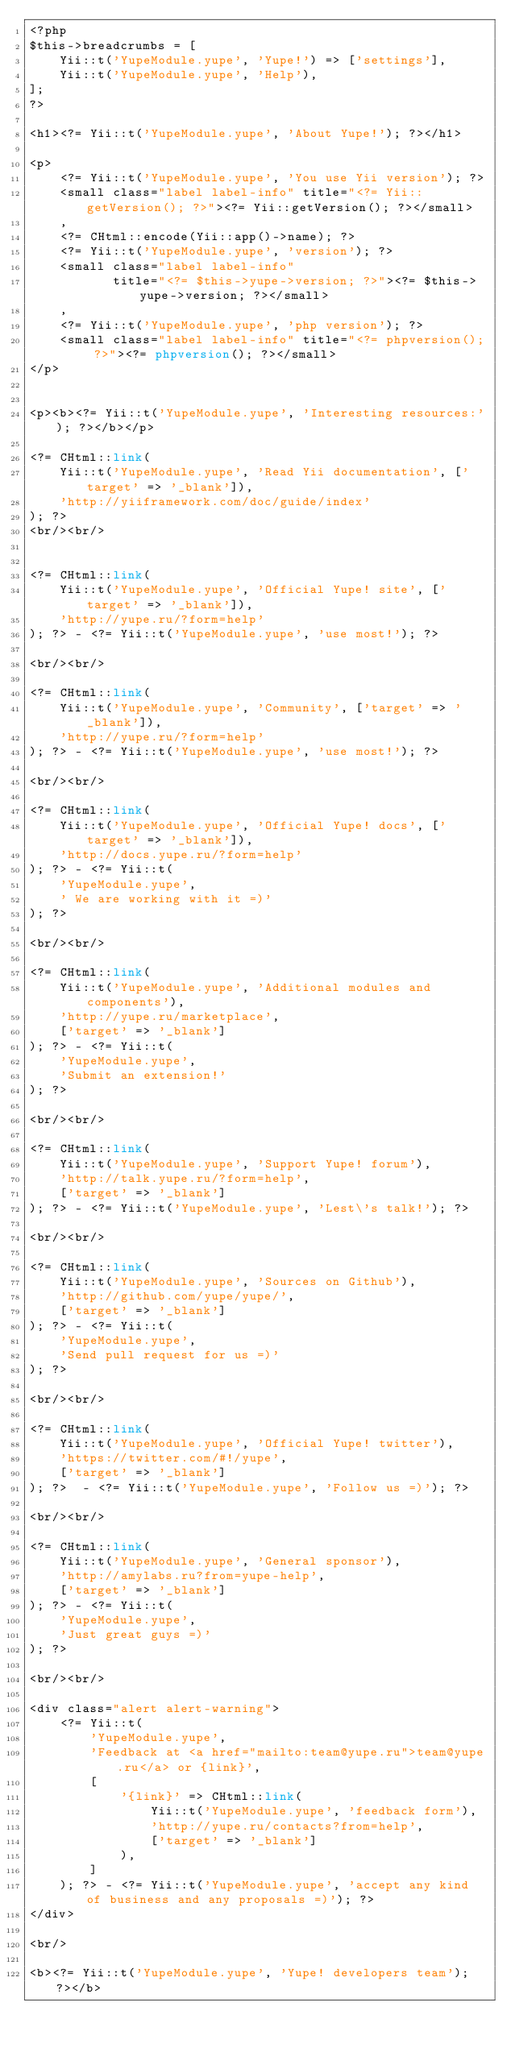<code> <loc_0><loc_0><loc_500><loc_500><_PHP_><?php
$this->breadcrumbs = [
    Yii::t('YupeModule.yupe', 'Yupe!') => ['settings'],
    Yii::t('YupeModule.yupe', 'Help'),
];
?>

<h1><?= Yii::t('YupeModule.yupe', 'About Yupe!'); ?></h1>

<p>
    <?= Yii::t('YupeModule.yupe', 'You use Yii version'); ?>
    <small class="label label-info" title="<?= Yii::getVersion(); ?>"><?= Yii::getVersion(); ?></small>
    ,
    <?= CHtml::encode(Yii::app()->name); ?>
    <?= Yii::t('YupeModule.yupe', 'version'); ?>
    <small class="label label-info"
           title="<?= $this->yupe->version; ?>"><?= $this->yupe->version; ?></small>
    ,
    <?= Yii::t('YupeModule.yupe', 'php version'); ?>
    <small class="label label-info" title="<?= phpversion(); ?>"><?= phpversion(); ?></small>
</p>


<p><b><?= Yii::t('YupeModule.yupe', 'Interesting resources:'); ?></b></p>

<?= CHtml::link(
    Yii::t('YupeModule.yupe', 'Read Yii documentation', ['target' => '_blank']),
    'http://yiiframework.com/doc/guide/index'
); ?>
<br/><br/>


<?= CHtml::link(
    Yii::t('YupeModule.yupe', 'Official Yupe! site', ['target' => '_blank']),
    'http://yupe.ru/?form=help'
); ?> - <?= Yii::t('YupeModule.yupe', 'use most!'); ?>

<br/><br/>

<?= CHtml::link(
    Yii::t('YupeModule.yupe', 'Community', ['target' => '_blank']),
    'http://yupe.ru/?form=help'
); ?> - <?= Yii::t('YupeModule.yupe', 'use most!'); ?>

<br/><br/>

<?= CHtml::link(
    Yii::t('YupeModule.yupe', 'Official Yupe! docs', ['target' => '_blank']),
    'http://docs.yupe.ru/?form=help'
); ?> - <?= Yii::t(
    'YupeModule.yupe',
    ' We are working with it =)'
); ?>

<br/><br/>

<?= CHtml::link(
    Yii::t('YupeModule.yupe', 'Additional modules and components'),
    'http://yupe.ru/marketplace',
    ['target' => '_blank']
); ?> - <?= Yii::t(
    'YupeModule.yupe',
    'Submit an extension!'
); ?>

<br/><br/>

<?= CHtml::link(
    Yii::t('YupeModule.yupe', 'Support Yupe! forum'),
    'http://talk.yupe.ru/?form=help',
    ['target' => '_blank']
); ?> - <?= Yii::t('YupeModule.yupe', 'Lest\'s talk!'); ?>

<br/><br/>

<?= CHtml::link(
    Yii::t('YupeModule.yupe', 'Sources on Github'),
    'http://github.com/yupe/yupe/',
    ['target' => '_blank']
); ?> - <?= Yii::t(
    'YupeModule.yupe',
    'Send pull request for us =)'
); ?>

<br/><br/>

<?= CHtml::link(
    Yii::t('YupeModule.yupe', 'Official Yupe! twitter'),
    'https://twitter.com/#!/yupe',
    ['target' => '_blank']
); ?>  - <?= Yii::t('YupeModule.yupe', 'Follow us =)'); ?>

<br/><br/>

<?= CHtml::link(
    Yii::t('YupeModule.yupe', 'General sponsor'),
    'http://amylabs.ru?from=yupe-help',
    ['target' => '_blank']
); ?> - <?= Yii::t(
    'YupeModule.yupe',
    'Just great guys =)'
); ?>

<br/><br/>

<div class="alert alert-warning">
    <?= Yii::t(
        'YupeModule.yupe',
        'Feedback at <a href="mailto:team@yupe.ru">team@yupe.ru</a> or {link}',
        [
            '{link}' => CHtml::link(
                Yii::t('YupeModule.yupe', 'feedback form'),
                'http://yupe.ru/contacts?from=help',
                ['target' => '_blank']
            ),
        ]
    ); ?> - <?= Yii::t('YupeModule.yupe', 'accept any kind of business and any proposals =)'); ?>
</div>

<br/>

<b><?= Yii::t('YupeModule.yupe', 'Yupe! developers team'); ?></b>


</code> 